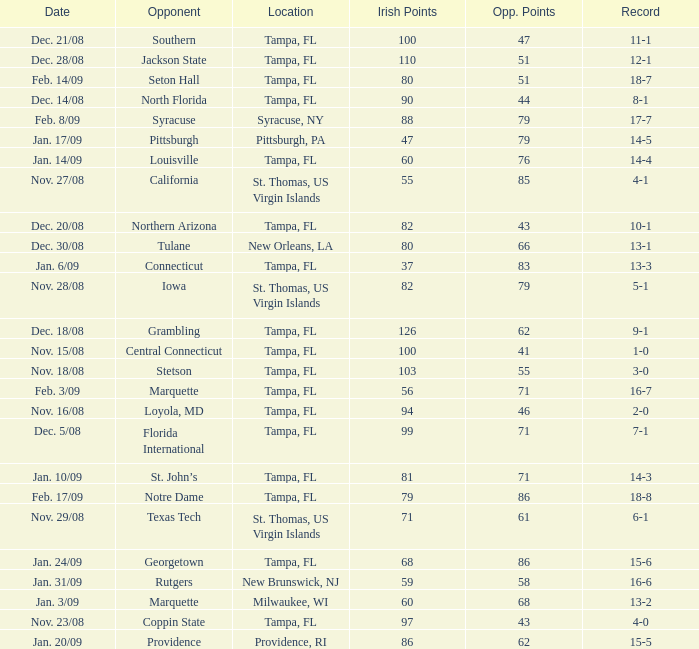What is the record where the opponent is central connecticut? 1-0. 